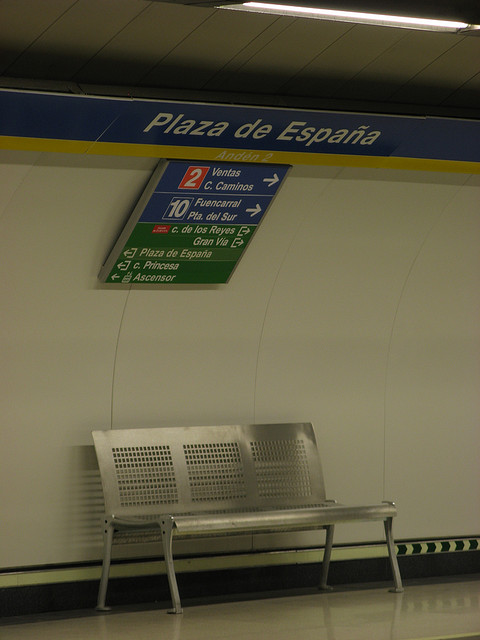How many benches are in the picture? 1 